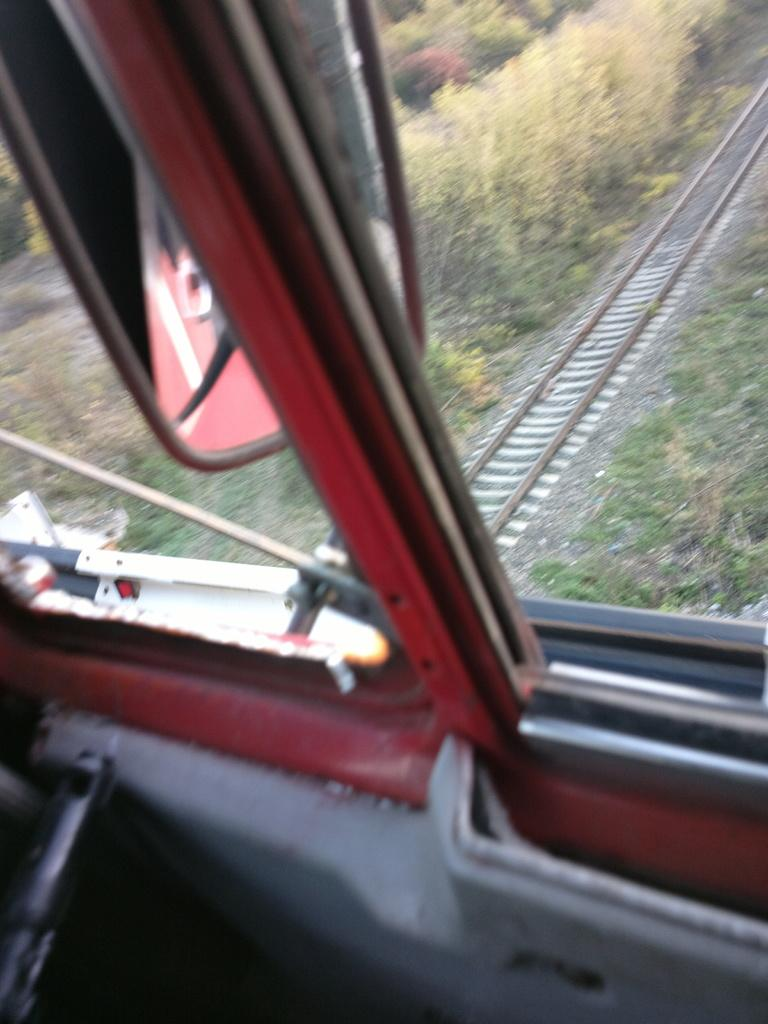What is the main subject in the front of the image? There is a vehicle in the front of the image. What can be seen in the background of the image? There are plants in the background of the image. What type of transportation infrastructure is visible in the image? A railway track is visible in the image. What type of vegetation is present at the bottom of the image? There is grass at the bottom of the image. How many apples are hanging from the vehicle in the image? There are no apples present in the image, and therefore no such objects can be observed hanging from the vehicle. 